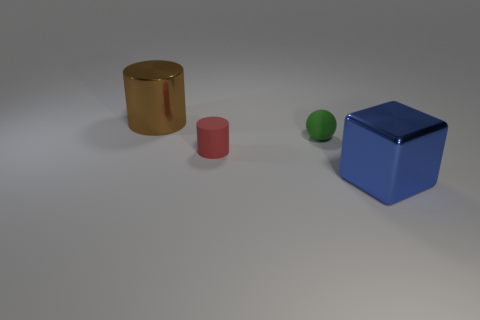What does the arrangement of these objects suggest about their purpose in this context? The arranged objects seem to be part of a still life composition, a common practice in both art and photography meant to focus on shape, form, and color. The diverse materials and colors could be a deliberate setup for studying light interaction with different surfaces. Furthermore, their even spacing and contrasting forms might be intended to provide a simple yet effective exercise in perspective and dimension analysis, or to compare and contrast the geometric shapes. 